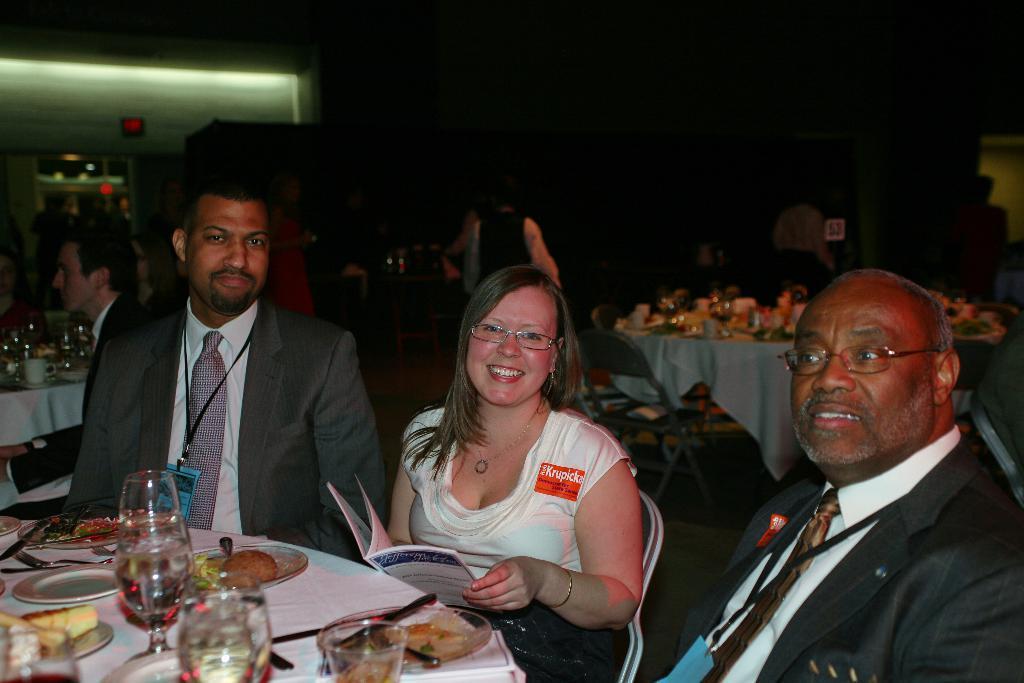Please provide a concise description of this image. This picture shows few people seated on the chairs and we see food in the plates and we see knives and spoons in the plate and we see few classes on the table and we see couple of men and woman seated on the chair and woman holding a book in her hand and men wore ID cards and we see couple of tables with cups glasses and plates on them and few people are standing and serving food. 